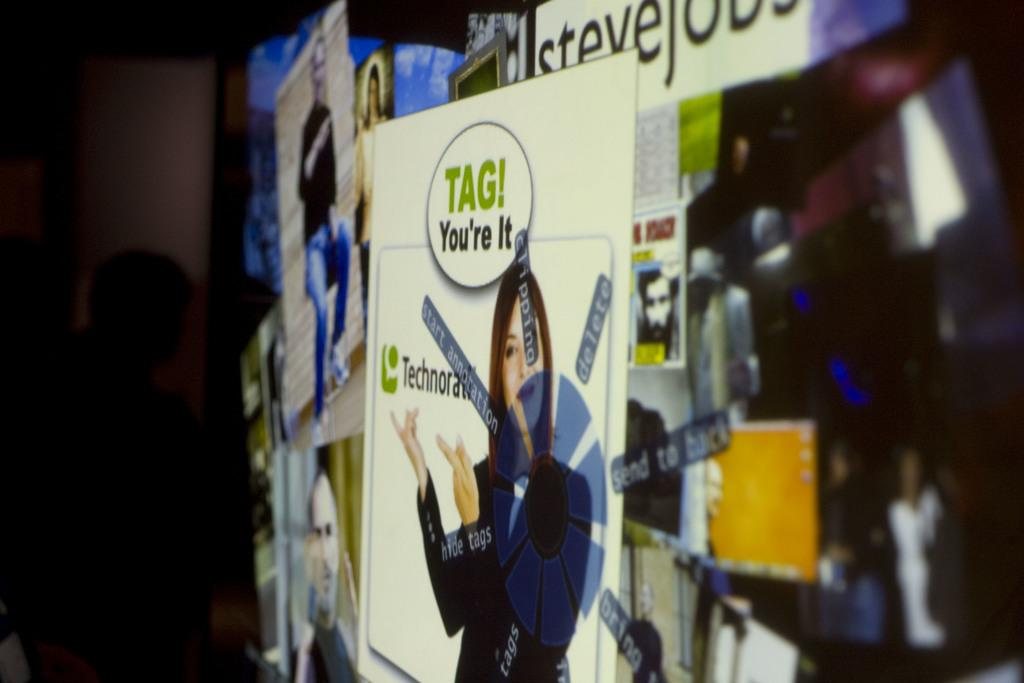<image>
Write a terse but informative summary of the picture. a sign with the word tag on it 